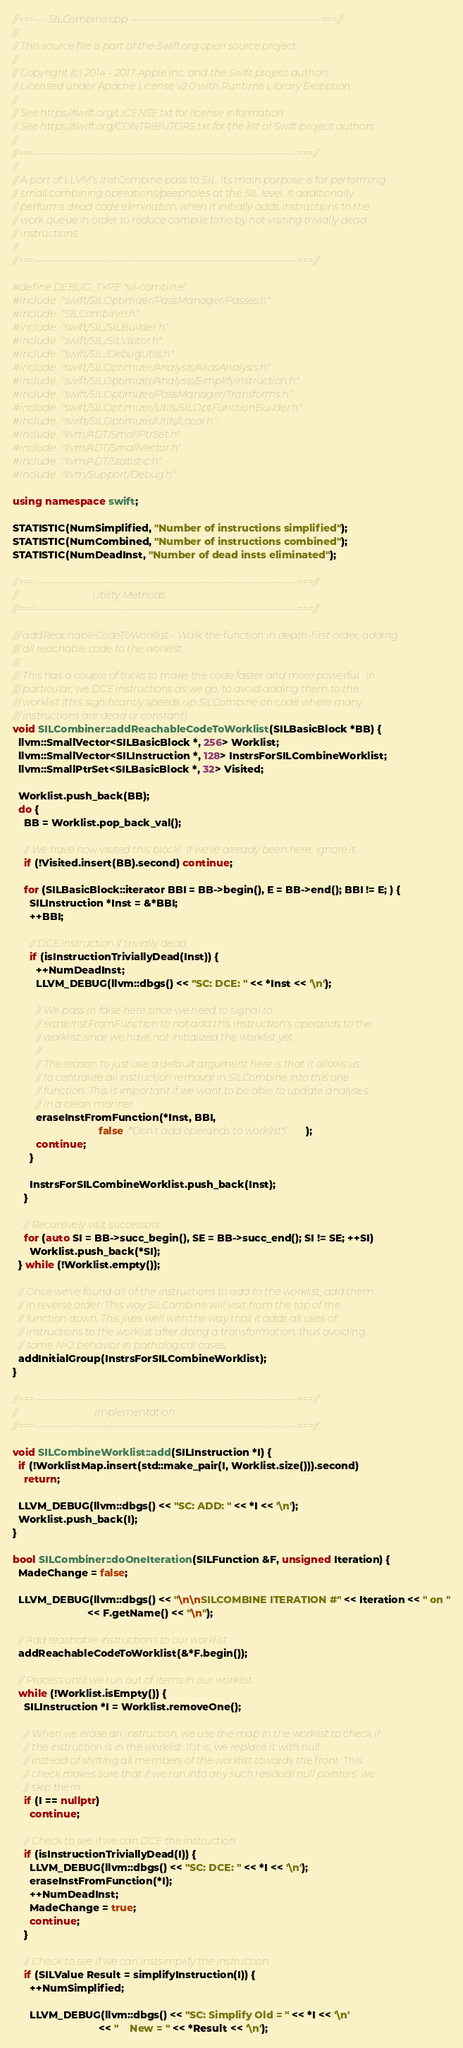Convert code to text. <code><loc_0><loc_0><loc_500><loc_500><_C++_>//===--- SILCombine.cpp ---------------------------------------------------===//
//
// This source file is part of the Swift.org open source project
//
// Copyright (c) 2014 - 2017 Apple Inc. and the Swift project authors
// Licensed under Apache License v2.0 with Runtime Library Exception
//
// See https://swift.org/LICENSE.txt for license information
// See https://swift.org/CONTRIBUTORS.txt for the list of Swift project authors
//
//===----------------------------------------------------------------------===//
//
// A port of LLVM's InstCombine pass to SIL. Its main purpose is for performing
// small combining operations/peepholes at the SIL level. It additionally
// performs dead code elimination when it initially adds instructions to the
// work queue in order to reduce compile time by not visiting trivially dead
// instructions.
//
//===----------------------------------------------------------------------===//

#define DEBUG_TYPE "sil-combine"
#include "swift/SILOptimizer/PassManager/Passes.h"
#include "SILCombiner.h"
#include "swift/SIL/SILBuilder.h"
#include "swift/SIL/SILVisitor.h"
#include "swift/SIL/DebugUtils.h"
#include "swift/SILOptimizer/Analysis/AliasAnalysis.h"
#include "swift/SILOptimizer/Analysis/SimplifyInstruction.h"
#include "swift/SILOptimizer/PassManager/Transforms.h"
#include "swift/SILOptimizer/Utils/SILOptFunctionBuilder.h"
#include "swift/SILOptimizer/Utils/Local.h"
#include "llvm/ADT/SmallPtrSet.h"
#include "llvm/ADT/SmallVector.h"
#include "llvm/ADT/Statistic.h"
#include "llvm/Support/Debug.h"

using namespace swift;

STATISTIC(NumSimplified, "Number of instructions simplified");
STATISTIC(NumCombined, "Number of instructions combined");
STATISTIC(NumDeadInst, "Number of dead insts eliminated");

//===----------------------------------------------------------------------===//
//                              Utility Methods
//===----------------------------------------------------------------------===//

/// addReachableCodeToWorklist - Walk the function in depth-first order, adding
/// all reachable code to the worklist.
///
/// This has a couple of tricks to make the code faster and more powerful.  In
/// particular, we DCE instructions as we go, to avoid adding them to the
/// worklist (this significantly speeds up SILCombine on code where many
/// instructions are dead or constant).
void SILCombiner::addReachableCodeToWorklist(SILBasicBlock *BB) {
  llvm::SmallVector<SILBasicBlock *, 256> Worklist;
  llvm::SmallVector<SILInstruction *, 128> InstrsForSILCombineWorklist;
  llvm::SmallPtrSet<SILBasicBlock *, 32> Visited;

  Worklist.push_back(BB);
  do {
    BB = Worklist.pop_back_val();

    // We have now visited this block!  If we've already been here, ignore it.
    if (!Visited.insert(BB).second) continue;

    for (SILBasicBlock::iterator BBI = BB->begin(), E = BB->end(); BBI != E; ) {
      SILInstruction *Inst = &*BBI;
      ++BBI;

      // DCE instruction if trivially dead.
      if (isInstructionTriviallyDead(Inst)) {
        ++NumDeadInst;
        LLVM_DEBUG(llvm::dbgs() << "SC: DCE: " << *Inst << '\n');

        // We pass in false here since we need to signal to
        // eraseInstFromFunction to not add this instruction's operands to the
        // worklist since we have not initialized the worklist yet.
        //
        // The reason to just use a default argument here is that it allows us
        // to centralize all instruction removal in SILCombine into this one
        // function. This is important if we want to be able to update analyses
        // in a clean manner.
        eraseInstFromFunction(*Inst, BBI,
                              false /*Don't add operands to worklist*/);
        continue;
      }

      InstrsForSILCombineWorklist.push_back(Inst);
    }

    // Recursively visit successors.
    for (auto SI = BB->succ_begin(), SE = BB->succ_end(); SI != SE; ++SI)
      Worklist.push_back(*SI);
  } while (!Worklist.empty());

  // Once we've found all of the instructions to add to the worklist, add them
  // in reverse order. This way SILCombine will visit from the top of the
  // function down. This jives well with the way that it adds all uses of
  // instructions to the worklist after doing a transformation, thus avoiding
  // some N^2 behavior in pathological cases.
  addInitialGroup(InstrsForSILCombineWorklist);
}

//===----------------------------------------------------------------------===//
//                               Implementation
//===----------------------------------------------------------------------===//

void SILCombineWorklist::add(SILInstruction *I) {
  if (!WorklistMap.insert(std::make_pair(I, Worklist.size())).second)
    return;

  LLVM_DEBUG(llvm::dbgs() << "SC: ADD: " << *I << '\n');
  Worklist.push_back(I);
}

bool SILCombiner::doOneIteration(SILFunction &F, unsigned Iteration) {
  MadeChange = false;

  LLVM_DEBUG(llvm::dbgs() << "\n\nSILCOMBINE ITERATION #" << Iteration << " on "
                          << F.getName() << "\n");

  // Add reachable instructions to our worklist.
  addReachableCodeToWorklist(&*F.begin());

  // Process until we run out of items in our worklist.
  while (!Worklist.isEmpty()) {
    SILInstruction *I = Worklist.removeOne();

    // When we erase an instruction, we use the map in the worklist to check if
    // the instruction is in the worklist. If it is, we replace it with null
    // instead of shifting all members of the worklist towards the front. This
    // check makes sure that if we run into any such residual null pointers, we
    // skip them.
    if (I == nullptr)
      continue;

    // Check to see if we can DCE the instruction.
    if (isInstructionTriviallyDead(I)) {
      LLVM_DEBUG(llvm::dbgs() << "SC: DCE: " << *I << '\n');
      eraseInstFromFunction(*I);
      ++NumDeadInst;
      MadeChange = true;
      continue;
    }

    // Check to see if we can instsimplify the instruction.
    if (SILValue Result = simplifyInstruction(I)) {
      ++NumSimplified;

      LLVM_DEBUG(llvm::dbgs() << "SC: Simplify Old = " << *I << '\n'
                              << "    New = " << *Result << '\n');
</code> 